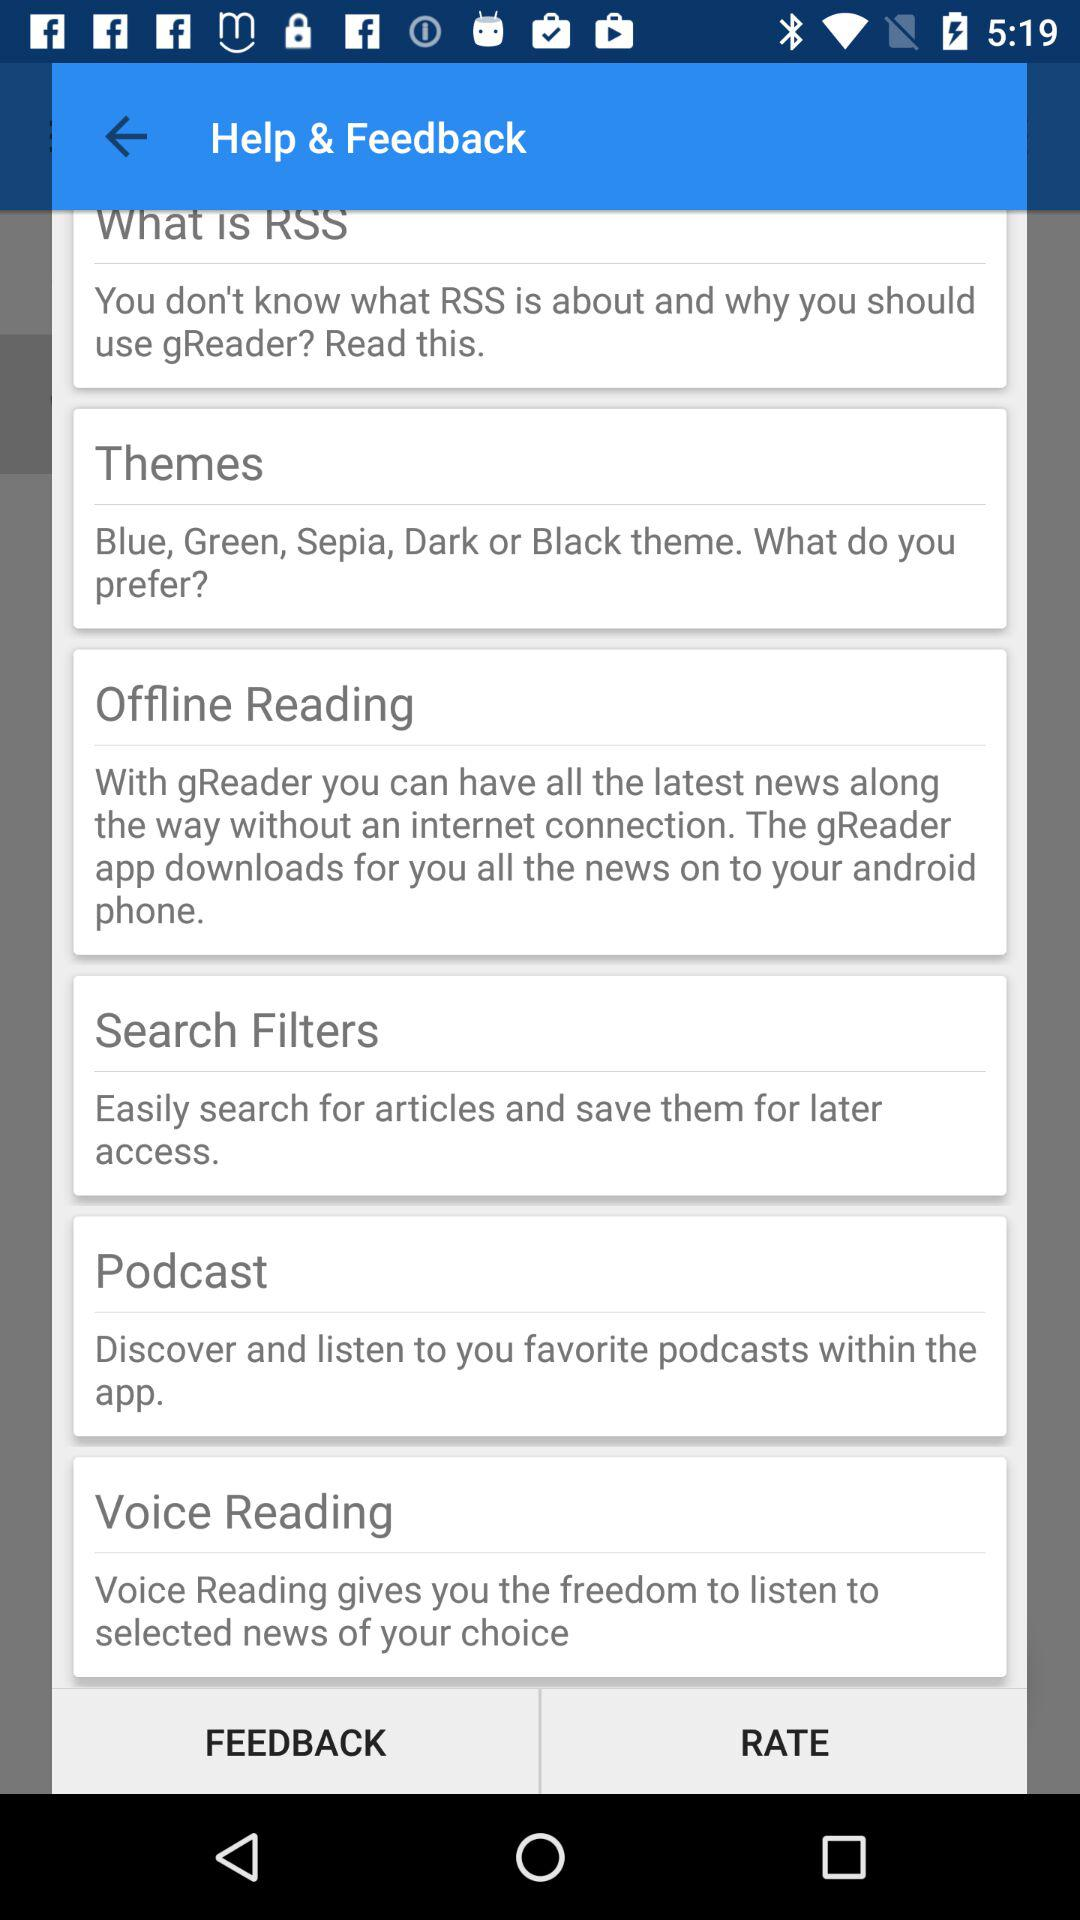What are the different available theme options? The different available theme options are "Blue", "Green", "Sepia", "Dark" and "Black". 